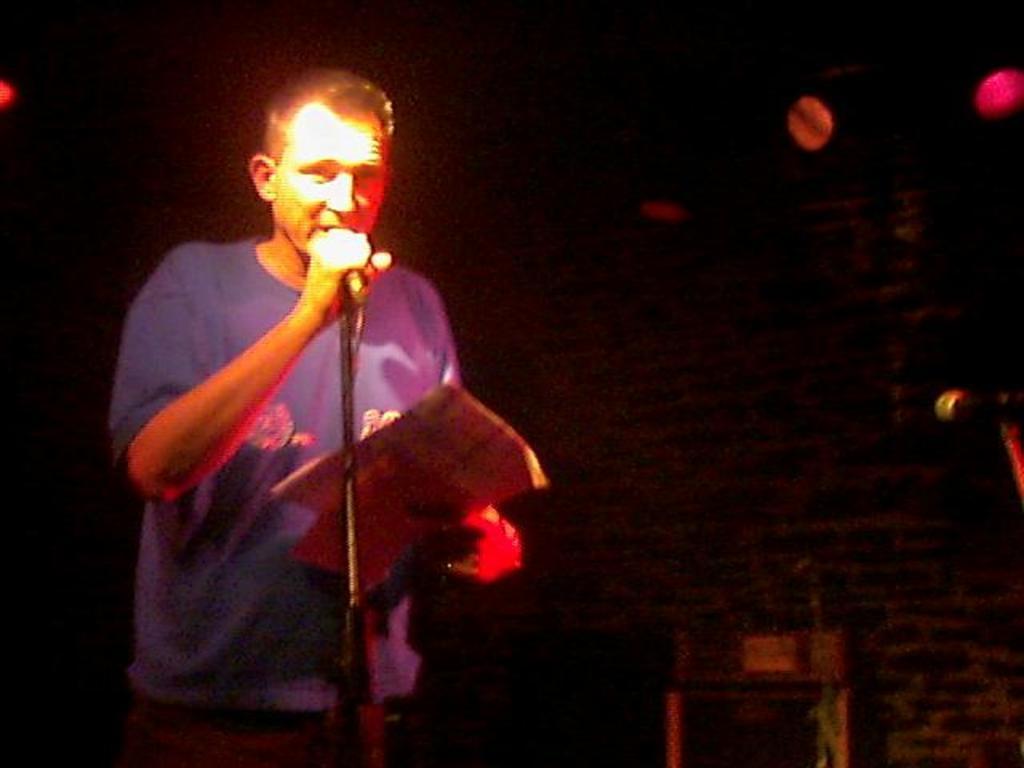How would you summarize this image in a sentence or two? a person is standing, speaking. in front of him there is a microphone. he is holding microphone in his hand. 